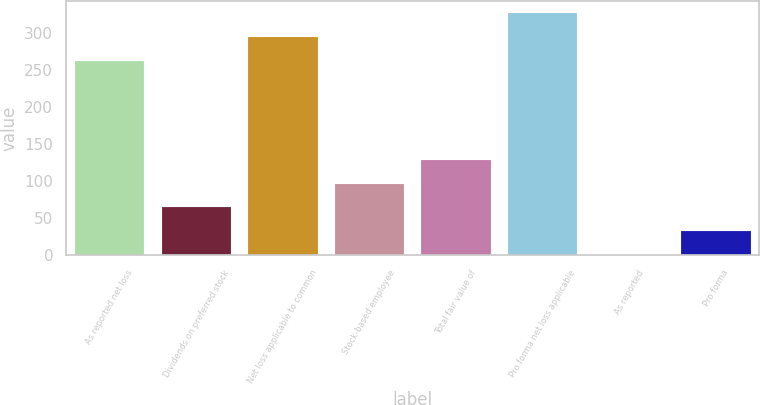<chart> <loc_0><loc_0><loc_500><loc_500><bar_chart><fcel>As reported net loss<fcel>Dividends on preferred stock<fcel>Net loss applicable to common<fcel>Stock-based employee<fcel>Total fair value of<fcel>Pro forma net loss applicable<fcel>As reported<fcel>Pro forma<nl><fcel>262.9<fcel>64.86<fcel>294.99<fcel>96.95<fcel>129.04<fcel>327.08<fcel>0.68<fcel>32.77<nl></chart> 